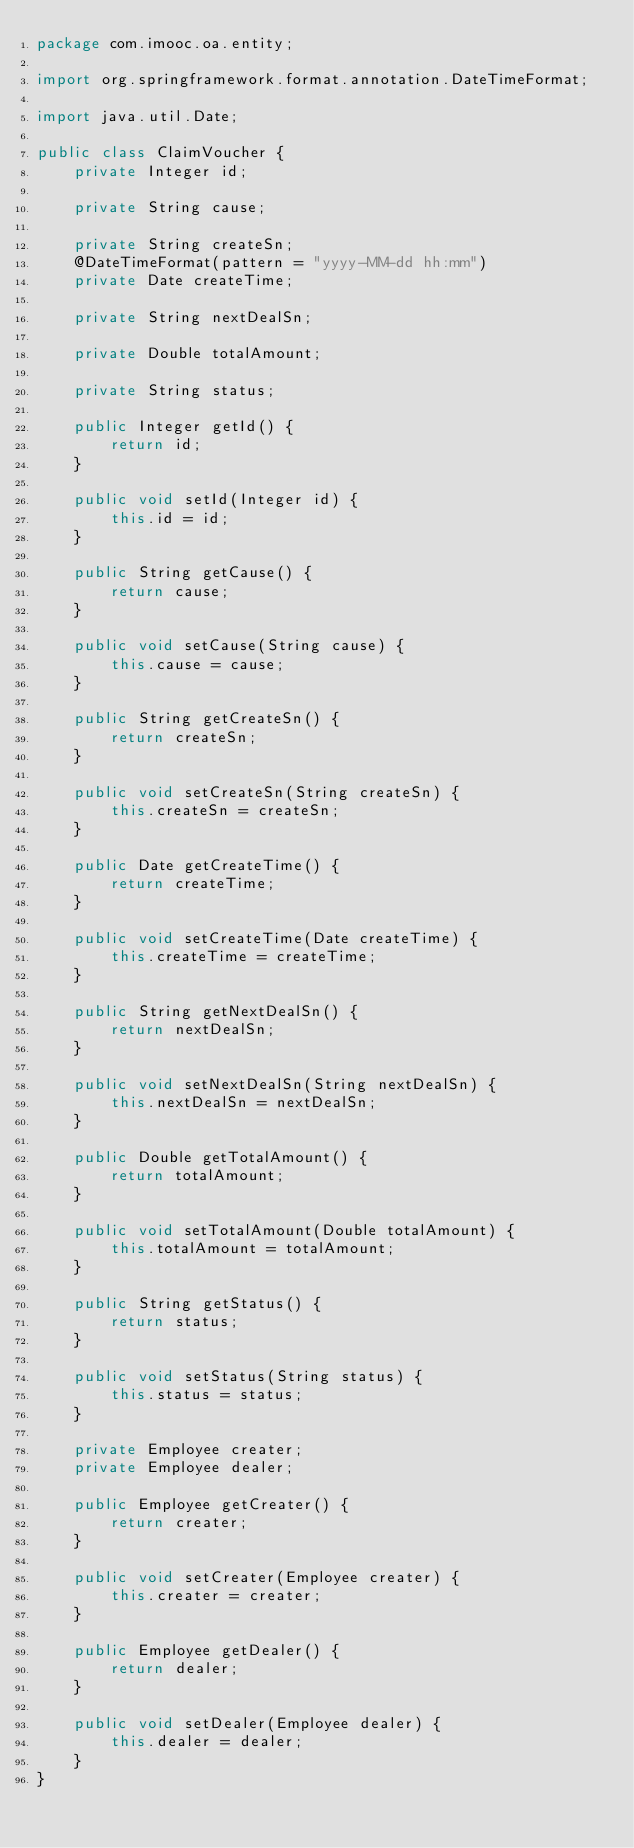<code> <loc_0><loc_0><loc_500><loc_500><_Java_>package com.imooc.oa.entity;

import org.springframework.format.annotation.DateTimeFormat;

import java.util.Date;

public class ClaimVoucher {
    private Integer id;

    private String cause;

    private String createSn;
    @DateTimeFormat(pattern = "yyyy-MM-dd hh:mm")
    private Date createTime;

    private String nextDealSn;

    private Double totalAmount;

    private String status;

    public Integer getId() {
        return id;
    }

    public void setId(Integer id) {
        this.id = id;
    }

    public String getCause() {
        return cause;
    }

    public void setCause(String cause) {
        this.cause = cause;
    }

    public String getCreateSn() {
        return createSn;
    }

    public void setCreateSn(String createSn) {
        this.createSn = createSn;
    }

    public Date getCreateTime() {
        return createTime;
    }

    public void setCreateTime(Date createTime) {
        this.createTime = createTime;
    }

    public String getNextDealSn() {
        return nextDealSn;
    }

    public void setNextDealSn(String nextDealSn) {
        this.nextDealSn = nextDealSn;
    }

    public Double getTotalAmount() {
        return totalAmount;
    }

    public void setTotalAmount(Double totalAmount) {
        this.totalAmount = totalAmount;
    }

    public String getStatus() {
        return status;
    }

    public void setStatus(String status) {
        this.status = status;
    }

    private Employee creater;
    private Employee dealer;

    public Employee getCreater() {
        return creater;
    }

    public void setCreater(Employee creater) {
        this.creater = creater;
    }

    public Employee getDealer() {
        return dealer;
    }

    public void setDealer(Employee dealer) {
        this.dealer = dealer;
    }
}</code> 